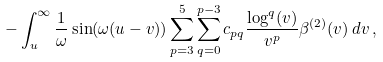<formula> <loc_0><loc_0><loc_500><loc_500>- \int _ { u } ^ { \infty } \frac { 1 } { \omega } \sin ( \omega ( u - v ) ) \sum _ { p = 3 } ^ { 5 } \sum _ { q = 0 } ^ { p - 3 } c _ { p q } \frac { \log ^ { q } ( v ) } { v ^ { p } } \beta ^ { ( 2 ) } ( v ) \, d v \, ,</formula> 